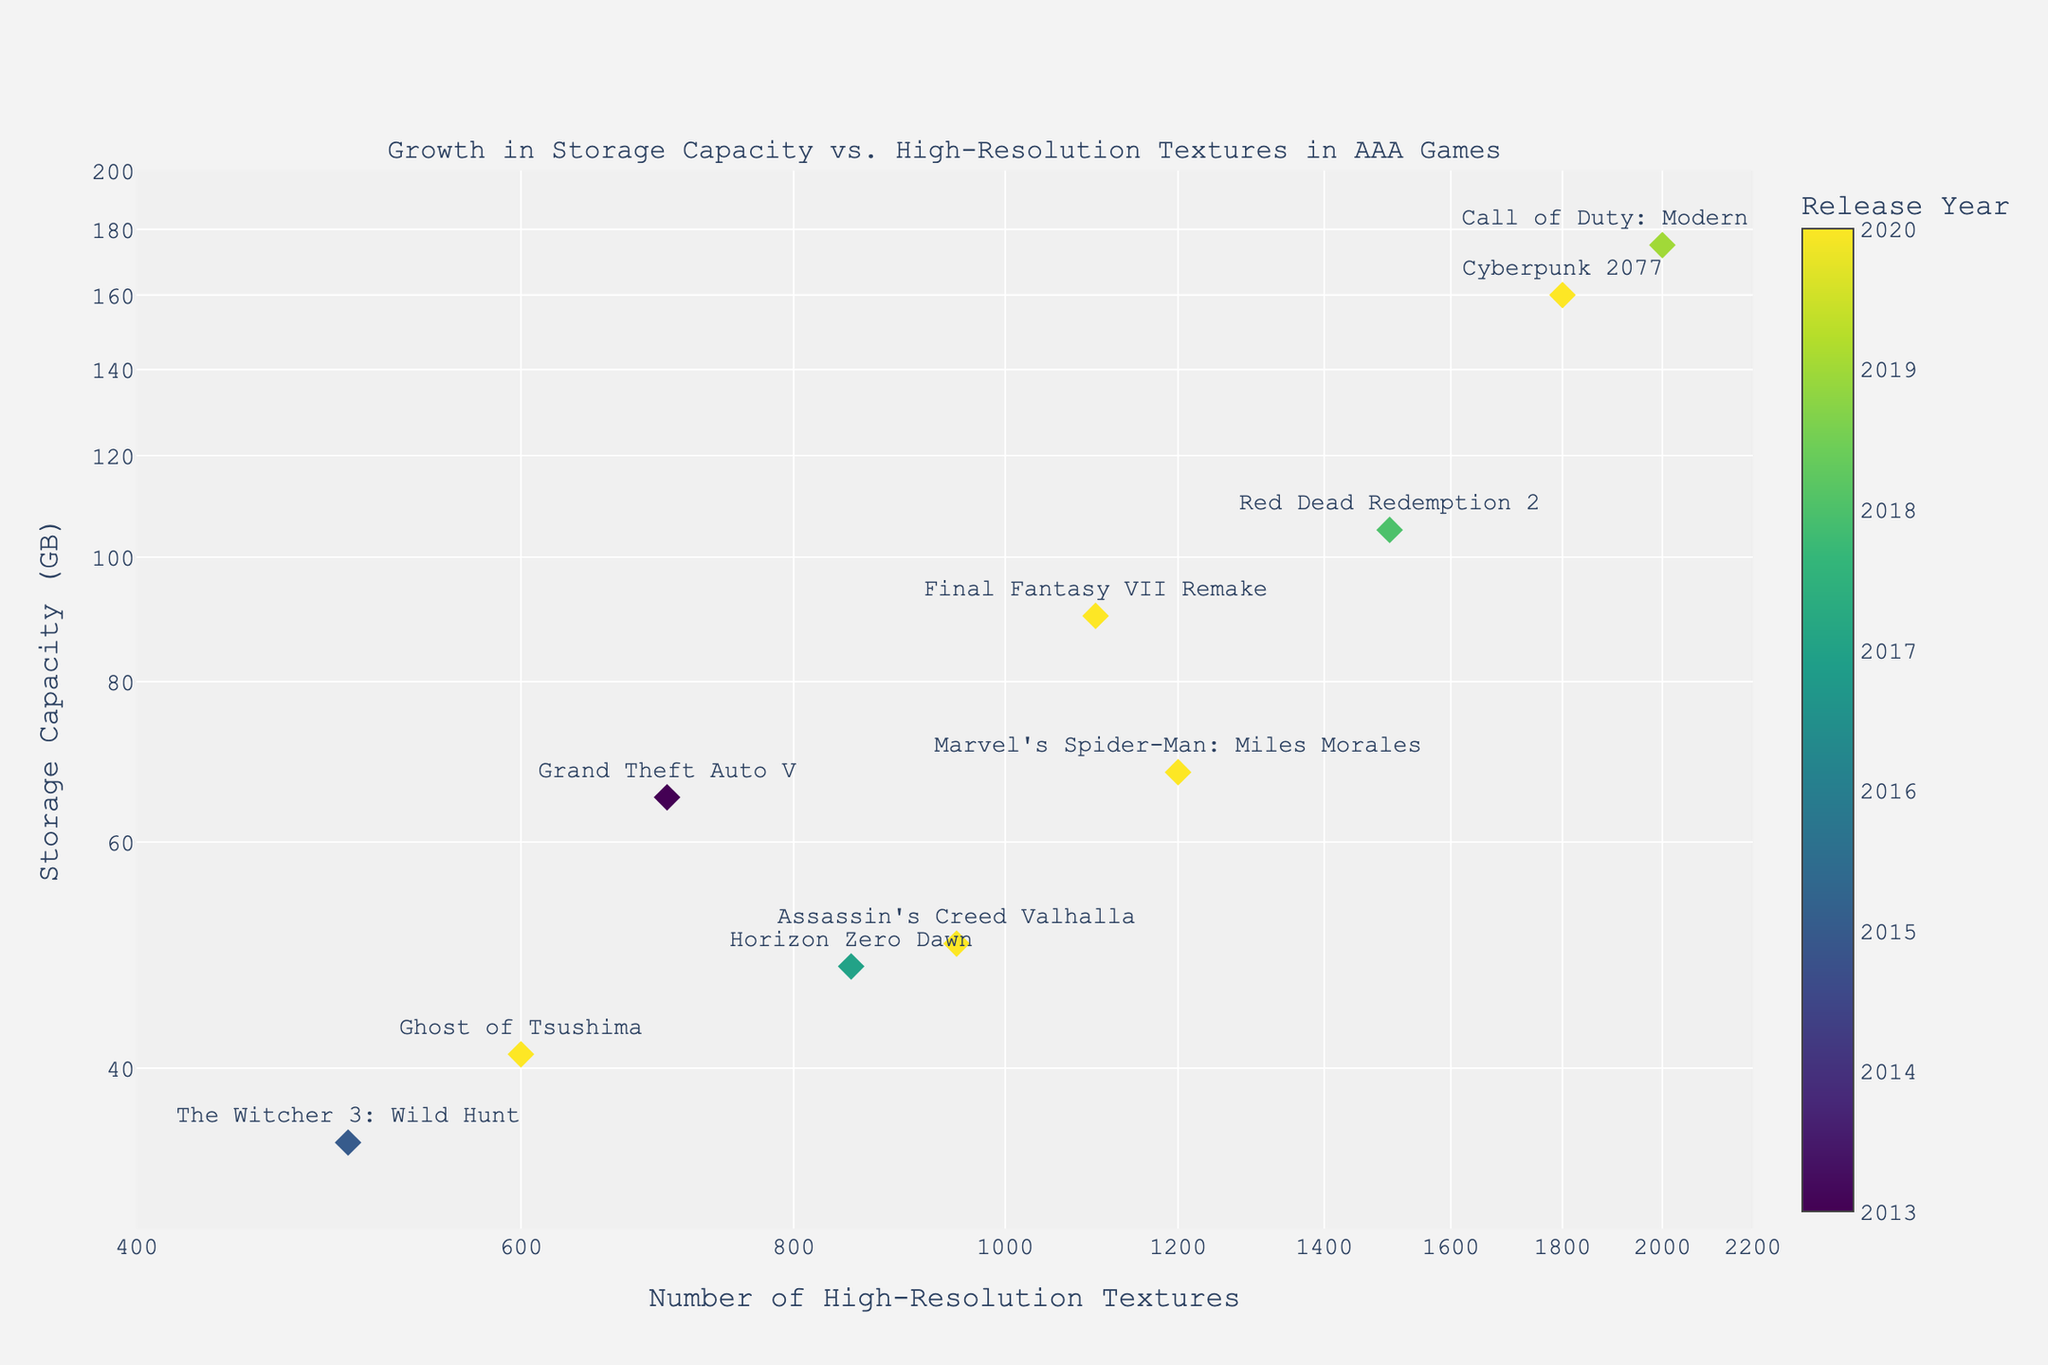What is the title of the figure? The title of the figure is usually placed at the top of the plot. In this case, it reads "Growth in Storage Capacity vs. High-Resolution Textures in AAA Games".
Answer: Growth in Storage Capacity vs. High-Resolution Textures in AAA Games Which axis represents the number of high-resolution textures? The horizontal axis (x-axis) represents the number of high-resolution textures, as indicated by the label "Number of High-Resolution Textures".
Answer: x-axis Which game has the highest storage capacity and what is its value? By looking at the points on the plot and hovering over the markers, the game with the highest storage capacity value is "Call of Duty: Modern Warfare" with 175 GB.
Answer: Call of Duty: Modern Warfare, 175 GB How do the storage capacity values compare between games released in 2020? By examining the data points for games released in 2020, "Cyberpunk 2077" has the highest storage capacity at 160 GB, followed by "Final Fantasy VII Remake" at 90 GB, "Marvel's Spider-Man: Miles Morales" at 68 GB, "Assassin's Creed Valhalla" at 50 GB, and "Ghost of Tsushima" at 41 GB.
Answer: Cyberpunk 2077 > Final Fantasy VII Remake > Marvel's Spider-Man: Miles Morales > Assassin's Creed Valhalla > Ghost of Tsushima What is the average storage capacity for the games listed? To find the average, sum all storage capacities and divide by the number of games. The total storage is 837 GB, with 10 games, so the average is 837/10 = 83.7 GB.
Answer: 83.7 GB Logarithmic Scales in the Figure: Why are they used? Logarithmic scales are used to handle a wide range of values and to make patterns more discernible, especially when data spans several orders of magnitude. It helps visualize proportional growth and rate changes clearly.
Answer: To handle wide range of values and discern patterns Which game has the lowest number of textures and what is its value? By examining the points on the plot, "The Witcher 3: Wild Hunt" has the lowest number of high-resolution textures at 500 units.
Answer: The Witcher 3: Wild Hunt, 500 Which game from 2020 has the most textures and how does that correlate with its storage capacity? In 2020, "Cyberpunk 2077" has the most textures at 1800 units, and it also has one of the highest storage capacities among the 2020 games at 160 GB, indicating a positive correlation.
Answer: Cyberpunk 2077, 1800 textures, 160 GB What's the range of the storage capacities in the figure? The smallest storage capacity is for "Ghost of Tsushima" at 41 GB, and the largest is for "Call of Duty: Modern Warfare" at 175 GB. The range is 175 - 41 = 134 GB.
Answer: 134 GB 